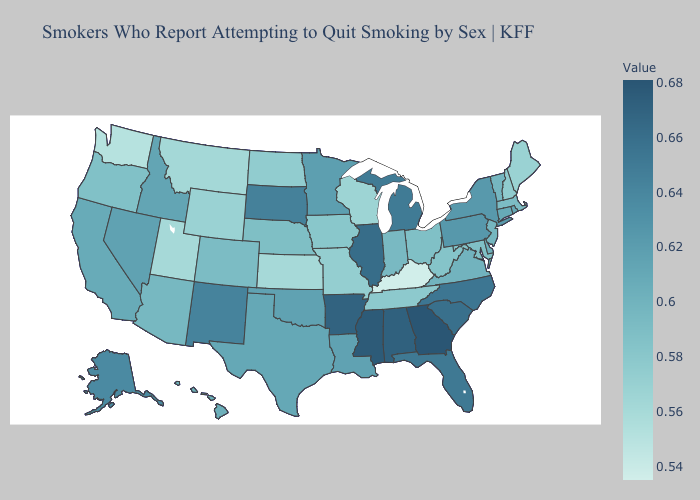Does Georgia have the highest value in the USA?
Write a very short answer. Yes. Does Arizona have a higher value than Pennsylvania?
Concise answer only. No. Does the map have missing data?
Answer briefly. No. Which states hav the highest value in the MidWest?
Quick response, please. Illinois. Does Vermont have the lowest value in the USA?
Keep it brief. No. 